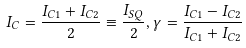<formula> <loc_0><loc_0><loc_500><loc_500>I _ { C } = \frac { I _ { C 1 } + I _ { C 2 } } { 2 } \equiv \frac { I _ { S Q } } { 2 } , \gamma = \frac { I _ { C 1 } - I _ { C 2 } } { I _ { C 1 } + I _ { C 2 } }</formula> 